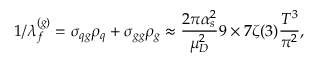Convert formula to latex. <formula><loc_0><loc_0><loc_500><loc_500>1 / \lambda _ { f } ^ { ( g ) } = \sigma _ { q g } \rho _ { q } + \sigma _ { g g } \rho _ { g } \approx \frac { 2 \pi \alpha _ { s } ^ { 2 } } { \mu _ { D } ^ { 2 } } 9 \times 7 \zeta ( 3 ) \frac { T ^ { 3 } } { \pi ^ { 2 } } ,</formula> 